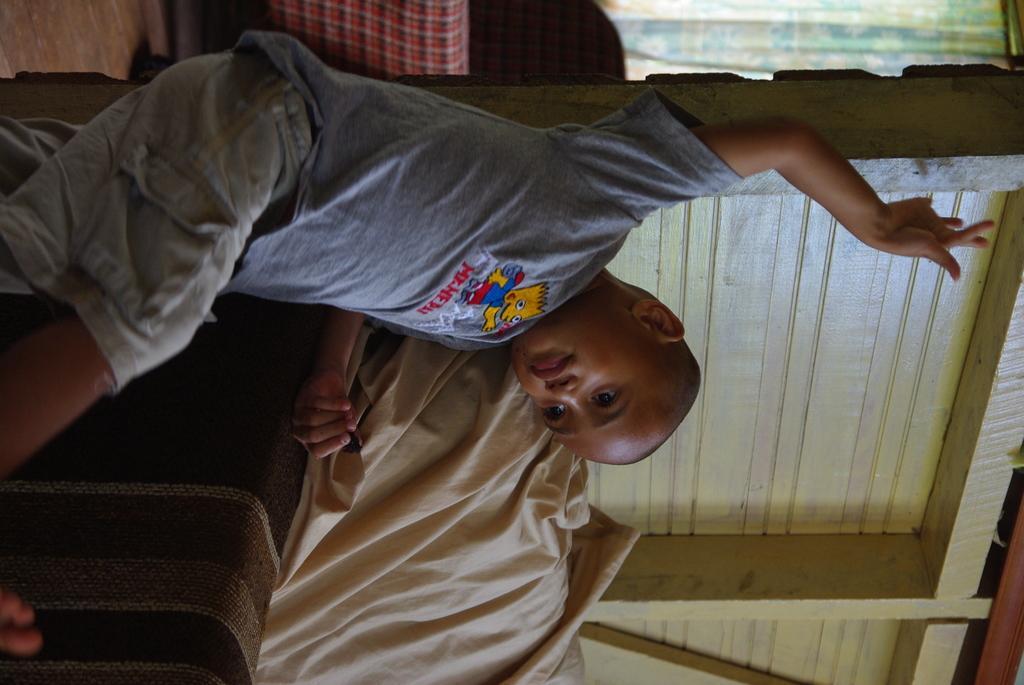Please provide a concise description of this image. On the left side, there is a boy in a gray color T-shirt, leaning on a sofa, on which there is a cloth. In the background, there is a wooden wall, a curtain and other objects. 